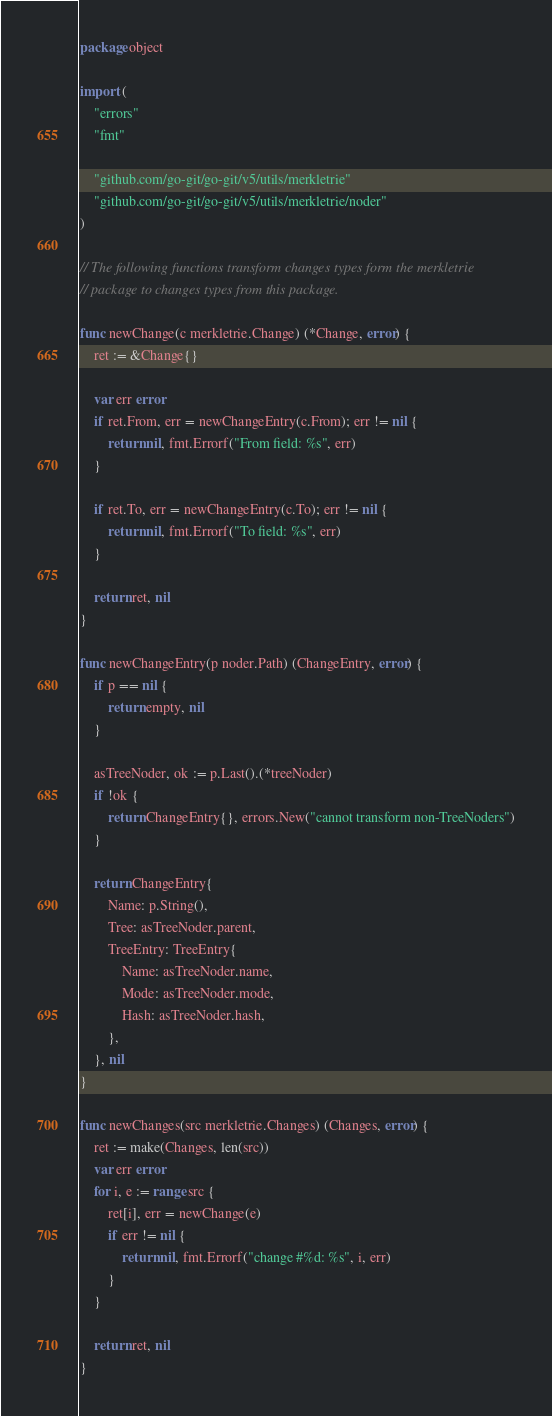<code> <loc_0><loc_0><loc_500><loc_500><_Go_>package object

import (
	"errors"
	"fmt"

	"github.com/go-git/go-git/v5/utils/merkletrie"
	"github.com/go-git/go-git/v5/utils/merkletrie/noder"
)

// The following functions transform changes types form the merkletrie
// package to changes types from this package.

func newChange(c merkletrie.Change) (*Change, error) {
	ret := &Change{}

	var err error
	if ret.From, err = newChangeEntry(c.From); err != nil {
		return nil, fmt.Errorf("From field: %s", err)
	}

	if ret.To, err = newChangeEntry(c.To); err != nil {
		return nil, fmt.Errorf("To field: %s", err)
	}

	return ret, nil
}

func newChangeEntry(p noder.Path) (ChangeEntry, error) {
	if p == nil {
		return empty, nil
	}

	asTreeNoder, ok := p.Last().(*treeNoder)
	if !ok {
		return ChangeEntry{}, errors.New("cannot transform non-TreeNoders")
	}

	return ChangeEntry{
		Name: p.String(),
		Tree: asTreeNoder.parent,
		TreeEntry: TreeEntry{
			Name: asTreeNoder.name,
			Mode: asTreeNoder.mode,
			Hash: asTreeNoder.hash,
		},
	}, nil
}

func newChanges(src merkletrie.Changes) (Changes, error) {
	ret := make(Changes, len(src))
	var err error
	for i, e := range src {
		ret[i], err = newChange(e)
		if err != nil {
			return nil, fmt.Errorf("change #%d: %s", i, err)
		}
	}

	return ret, nil
}
</code> 